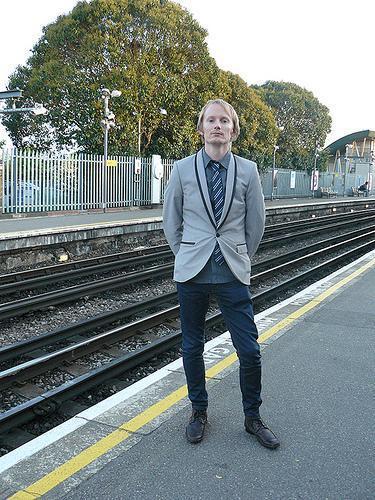How many horses are pulling the carriage?
Give a very brief answer. 0. 